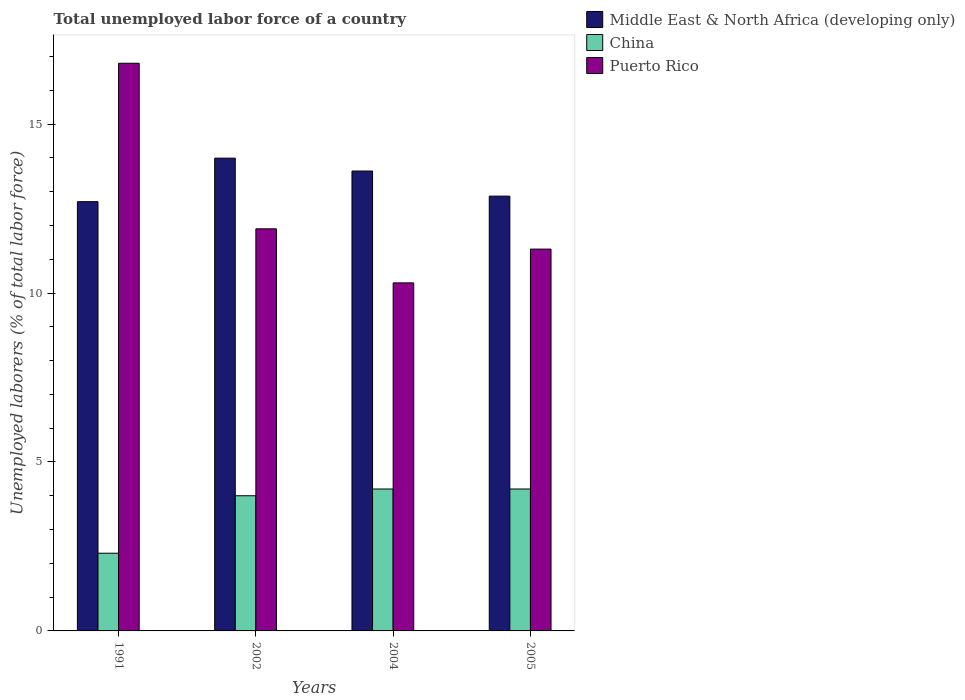Are the number of bars per tick equal to the number of legend labels?
Ensure brevity in your answer.  Yes. Are the number of bars on each tick of the X-axis equal?
Your answer should be compact. Yes. How many bars are there on the 3rd tick from the left?
Make the answer very short. 3. How many bars are there on the 2nd tick from the right?
Provide a short and direct response. 3. What is the label of the 2nd group of bars from the left?
Provide a succinct answer. 2002. In how many cases, is the number of bars for a given year not equal to the number of legend labels?
Offer a very short reply. 0. What is the total unemployed labor force in Puerto Rico in 1991?
Your response must be concise. 16.8. Across all years, what is the maximum total unemployed labor force in China?
Your answer should be very brief. 4.2. Across all years, what is the minimum total unemployed labor force in Middle East & North Africa (developing only)?
Make the answer very short. 12.7. What is the total total unemployed labor force in China in the graph?
Your response must be concise. 14.7. What is the difference between the total unemployed labor force in China in 1991 and that in 2004?
Provide a short and direct response. -1.9. What is the difference between the total unemployed labor force in China in 2005 and the total unemployed labor force in Middle East & North Africa (developing only) in 2004?
Keep it short and to the point. -9.41. What is the average total unemployed labor force in China per year?
Your response must be concise. 3.67. In the year 2005, what is the difference between the total unemployed labor force in Puerto Rico and total unemployed labor force in Middle East & North Africa (developing only)?
Your response must be concise. -1.57. What is the ratio of the total unemployed labor force in Middle East & North Africa (developing only) in 1991 to that in 2005?
Offer a terse response. 0.99. Is the difference between the total unemployed labor force in Puerto Rico in 2004 and 2005 greater than the difference between the total unemployed labor force in Middle East & North Africa (developing only) in 2004 and 2005?
Give a very brief answer. No. What is the difference between the highest and the second highest total unemployed labor force in Puerto Rico?
Make the answer very short. 4.9. What is the difference between the highest and the lowest total unemployed labor force in Middle East & North Africa (developing only)?
Your response must be concise. 1.29. Is the sum of the total unemployed labor force in Middle East & North Africa (developing only) in 1991 and 2002 greater than the maximum total unemployed labor force in China across all years?
Provide a short and direct response. Yes. What does the 2nd bar from the left in 2005 represents?
Keep it short and to the point. China. What does the 2nd bar from the right in 2002 represents?
Offer a very short reply. China. Are all the bars in the graph horizontal?
Provide a succinct answer. No. How many years are there in the graph?
Provide a succinct answer. 4. Does the graph contain any zero values?
Make the answer very short. No. Where does the legend appear in the graph?
Provide a short and direct response. Top right. What is the title of the graph?
Give a very brief answer. Total unemployed labor force of a country. Does "Mauritania" appear as one of the legend labels in the graph?
Your answer should be compact. No. What is the label or title of the X-axis?
Your answer should be very brief. Years. What is the label or title of the Y-axis?
Ensure brevity in your answer.  Unemployed laborers (% of total labor force). What is the Unemployed laborers (% of total labor force) of Middle East & North Africa (developing only) in 1991?
Your answer should be compact. 12.7. What is the Unemployed laborers (% of total labor force) of China in 1991?
Provide a succinct answer. 2.3. What is the Unemployed laborers (% of total labor force) in Puerto Rico in 1991?
Your answer should be compact. 16.8. What is the Unemployed laborers (% of total labor force) in Middle East & North Africa (developing only) in 2002?
Give a very brief answer. 13.99. What is the Unemployed laborers (% of total labor force) in China in 2002?
Offer a terse response. 4. What is the Unemployed laborers (% of total labor force) in Puerto Rico in 2002?
Your answer should be compact. 11.9. What is the Unemployed laborers (% of total labor force) in Middle East & North Africa (developing only) in 2004?
Offer a terse response. 13.61. What is the Unemployed laborers (% of total labor force) of China in 2004?
Your answer should be compact. 4.2. What is the Unemployed laborers (% of total labor force) of Puerto Rico in 2004?
Make the answer very short. 10.3. What is the Unemployed laborers (% of total labor force) of Middle East & North Africa (developing only) in 2005?
Your answer should be compact. 12.87. What is the Unemployed laborers (% of total labor force) of China in 2005?
Make the answer very short. 4.2. What is the Unemployed laborers (% of total labor force) in Puerto Rico in 2005?
Your answer should be very brief. 11.3. Across all years, what is the maximum Unemployed laborers (% of total labor force) in Middle East & North Africa (developing only)?
Offer a terse response. 13.99. Across all years, what is the maximum Unemployed laborers (% of total labor force) in China?
Make the answer very short. 4.2. Across all years, what is the maximum Unemployed laborers (% of total labor force) of Puerto Rico?
Ensure brevity in your answer.  16.8. Across all years, what is the minimum Unemployed laborers (% of total labor force) of Middle East & North Africa (developing only)?
Provide a short and direct response. 12.7. Across all years, what is the minimum Unemployed laborers (% of total labor force) of China?
Ensure brevity in your answer.  2.3. Across all years, what is the minimum Unemployed laborers (% of total labor force) of Puerto Rico?
Offer a very short reply. 10.3. What is the total Unemployed laborers (% of total labor force) in Middle East & North Africa (developing only) in the graph?
Offer a very short reply. 53.17. What is the total Unemployed laborers (% of total labor force) in China in the graph?
Offer a terse response. 14.7. What is the total Unemployed laborers (% of total labor force) in Puerto Rico in the graph?
Your response must be concise. 50.3. What is the difference between the Unemployed laborers (% of total labor force) in Middle East & North Africa (developing only) in 1991 and that in 2002?
Make the answer very short. -1.29. What is the difference between the Unemployed laborers (% of total labor force) in Puerto Rico in 1991 and that in 2002?
Offer a terse response. 4.9. What is the difference between the Unemployed laborers (% of total labor force) of Middle East & North Africa (developing only) in 1991 and that in 2004?
Your answer should be compact. -0.91. What is the difference between the Unemployed laborers (% of total labor force) of Middle East & North Africa (developing only) in 1991 and that in 2005?
Your answer should be very brief. -0.16. What is the difference between the Unemployed laborers (% of total labor force) of China in 1991 and that in 2005?
Make the answer very short. -1.9. What is the difference between the Unemployed laborers (% of total labor force) of Middle East & North Africa (developing only) in 2002 and that in 2004?
Your answer should be very brief. 0.38. What is the difference between the Unemployed laborers (% of total labor force) in China in 2002 and that in 2004?
Keep it short and to the point. -0.2. What is the difference between the Unemployed laborers (% of total labor force) in Middle East & North Africa (developing only) in 2002 and that in 2005?
Make the answer very short. 1.12. What is the difference between the Unemployed laborers (% of total labor force) in Puerto Rico in 2002 and that in 2005?
Provide a short and direct response. 0.6. What is the difference between the Unemployed laborers (% of total labor force) in Middle East & North Africa (developing only) in 2004 and that in 2005?
Your response must be concise. 0.74. What is the difference between the Unemployed laborers (% of total labor force) in China in 2004 and that in 2005?
Keep it short and to the point. 0. What is the difference between the Unemployed laborers (% of total labor force) of Middle East & North Africa (developing only) in 1991 and the Unemployed laborers (% of total labor force) of China in 2002?
Your response must be concise. 8.7. What is the difference between the Unemployed laborers (% of total labor force) of Middle East & North Africa (developing only) in 1991 and the Unemployed laborers (% of total labor force) of Puerto Rico in 2002?
Offer a terse response. 0.8. What is the difference between the Unemployed laborers (% of total labor force) of Middle East & North Africa (developing only) in 1991 and the Unemployed laborers (% of total labor force) of China in 2004?
Give a very brief answer. 8.5. What is the difference between the Unemployed laborers (% of total labor force) in Middle East & North Africa (developing only) in 1991 and the Unemployed laborers (% of total labor force) in Puerto Rico in 2004?
Provide a succinct answer. 2.4. What is the difference between the Unemployed laborers (% of total labor force) of Middle East & North Africa (developing only) in 1991 and the Unemployed laborers (% of total labor force) of China in 2005?
Keep it short and to the point. 8.5. What is the difference between the Unemployed laborers (% of total labor force) in Middle East & North Africa (developing only) in 1991 and the Unemployed laborers (% of total labor force) in Puerto Rico in 2005?
Keep it short and to the point. 1.4. What is the difference between the Unemployed laborers (% of total labor force) of China in 1991 and the Unemployed laborers (% of total labor force) of Puerto Rico in 2005?
Offer a very short reply. -9. What is the difference between the Unemployed laborers (% of total labor force) of Middle East & North Africa (developing only) in 2002 and the Unemployed laborers (% of total labor force) of China in 2004?
Give a very brief answer. 9.79. What is the difference between the Unemployed laborers (% of total labor force) in Middle East & North Africa (developing only) in 2002 and the Unemployed laborers (% of total labor force) in Puerto Rico in 2004?
Offer a terse response. 3.69. What is the difference between the Unemployed laborers (% of total labor force) of China in 2002 and the Unemployed laborers (% of total labor force) of Puerto Rico in 2004?
Ensure brevity in your answer.  -6.3. What is the difference between the Unemployed laborers (% of total labor force) in Middle East & North Africa (developing only) in 2002 and the Unemployed laborers (% of total labor force) in China in 2005?
Offer a very short reply. 9.79. What is the difference between the Unemployed laborers (% of total labor force) in Middle East & North Africa (developing only) in 2002 and the Unemployed laborers (% of total labor force) in Puerto Rico in 2005?
Keep it short and to the point. 2.69. What is the difference between the Unemployed laborers (% of total labor force) of China in 2002 and the Unemployed laborers (% of total labor force) of Puerto Rico in 2005?
Provide a short and direct response. -7.3. What is the difference between the Unemployed laborers (% of total labor force) in Middle East & North Africa (developing only) in 2004 and the Unemployed laborers (% of total labor force) in China in 2005?
Provide a short and direct response. 9.41. What is the difference between the Unemployed laborers (% of total labor force) of Middle East & North Africa (developing only) in 2004 and the Unemployed laborers (% of total labor force) of Puerto Rico in 2005?
Your response must be concise. 2.31. What is the average Unemployed laborers (% of total labor force) of Middle East & North Africa (developing only) per year?
Offer a very short reply. 13.29. What is the average Unemployed laborers (% of total labor force) of China per year?
Ensure brevity in your answer.  3.67. What is the average Unemployed laborers (% of total labor force) in Puerto Rico per year?
Provide a succinct answer. 12.57. In the year 1991, what is the difference between the Unemployed laborers (% of total labor force) of Middle East & North Africa (developing only) and Unemployed laborers (% of total labor force) of China?
Provide a succinct answer. 10.4. In the year 1991, what is the difference between the Unemployed laborers (% of total labor force) of Middle East & North Africa (developing only) and Unemployed laborers (% of total labor force) of Puerto Rico?
Provide a succinct answer. -4.1. In the year 1991, what is the difference between the Unemployed laborers (% of total labor force) of China and Unemployed laborers (% of total labor force) of Puerto Rico?
Your answer should be compact. -14.5. In the year 2002, what is the difference between the Unemployed laborers (% of total labor force) of Middle East & North Africa (developing only) and Unemployed laborers (% of total labor force) of China?
Offer a terse response. 9.99. In the year 2002, what is the difference between the Unemployed laborers (% of total labor force) in Middle East & North Africa (developing only) and Unemployed laborers (% of total labor force) in Puerto Rico?
Offer a terse response. 2.09. In the year 2002, what is the difference between the Unemployed laborers (% of total labor force) of China and Unemployed laborers (% of total labor force) of Puerto Rico?
Offer a terse response. -7.9. In the year 2004, what is the difference between the Unemployed laborers (% of total labor force) in Middle East & North Africa (developing only) and Unemployed laborers (% of total labor force) in China?
Make the answer very short. 9.41. In the year 2004, what is the difference between the Unemployed laborers (% of total labor force) in Middle East & North Africa (developing only) and Unemployed laborers (% of total labor force) in Puerto Rico?
Provide a succinct answer. 3.31. In the year 2005, what is the difference between the Unemployed laborers (% of total labor force) of Middle East & North Africa (developing only) and Unemployed laborers (% of total labor force) of China?
Your answer should be very brief. 8.67. In the year 2005, what is the difference between the Unemployed laborers (% of total labor force) of Middle East & North Africa (developing only) and Unemployed laborers (% of total labor force) of Puerto Rico?
Offer a terse response. 1.57. In the year 2005, what is the difference between the Unemployed laborers (% of total labor force) in China and Unemployed laborers (% of total labor force) in Puerto Rico?
Your answer should be very brief. -7.1. What is the ratio of the Unemployed laborers (% of total labor force) in Middle East & North Africa (developing only) in 1991 to that in 2002?
Provide a succinct answer. 0.91. What is the ratio of the Unemployed laborers (% of total labor force) in China in 1991 to that in 2002?
Your answer should be compact. 0.57. What is the ratio of the Unemployed laborers (% of total labor force) in Puerto Rico in 1991 to that in 2002?
Ensure brevity in your answer.  1.41. What is the ratio of the Unemployed laborers (% of total labor force) in Middle East & North Africa (developing only) in 1991 to that in 2004?
Offer a terse response. 0.93. What is the ratio of the Unemployed laborers (% of total labor force) in China in 1991 to that in 2004?
Your answer should be very brief. 0.55. What is the ratio of the Unemployed laborers (% of total labor force) in Puerto Rico in 1991 to that in 2004?
Provide a succinct answer. 1.63. What is the ratio of the Unemployed laborers (% of total labor force) of Middle East & North Africa (developing only) in 1991 to that in 2005?
Your answer should be very brief. 0.99. What is the ratio of the Unemployed laborers (% of total labor force) of China in 1991 to that in 2005?
Give a very brief answer. 0.55. What is the ratio of the Unemployed laborers (% of total labor force) in Puerto Rico in 1991 to that in 2005?
Make the answer very short. 1.49. What is the ratio of the Unemployed laborers (% of total labor force) of Middle East & North Africa (developing only) in 2002 to that in 2004?
Make the answer very short. 1.03. What is the ratio of the Unemployed laborers (% of total labor force) of China in 2002 to that in 2004?
Give a very brief answer. 0.95. What is the ratio of the Unemployed laborers (% of total labor force) of Puerto Rico in 2002 to that in 2004?
Your answer should be very brief. 1.16. What is the ratio of the Unemployed laborers (% of total labor force) of Middle East & North Africa (developing only) in 2002 to that in 2005?
Your response must be concise. 1.09. What is the ratio of the Unemployed laborers (% of total labor force) in Puerto Rico in 2002 to that in 2005?
Make the answer very short. 1.05. What is the ratio of the Unemployed laborers (% of total labor force) in Middle East & North Africa (developing only) in 2004 to that in 2005?
Keep it short and to the point. 1.06. What is the ratio of the Unemployed laborers (% of total labor force) in China in 2004 to that in 2005?
Provide a short and direct response. 1. What is the ratio of the Unemployed laborers (% of total labor force) of Puerto Rico in 2004 to that in 2005?
Offer a terse response. 0.91. What is the difference between the highest and the second highest Unemployed laborers (% of total labor force) in Middle East & North Africa (developing only)?
Your answer should be very brief. 0.38. What is the difference between the highest and the lowest Unemployed laborers (% of total labor force) in Middle East & North Africa (developing only)?
Your response must be concise. 1.29. What is the difference between the highest and the lowest Unemployed laborers (% of total labor force) in Puerto Rico?
Provide a short and direct response. 6.5. 